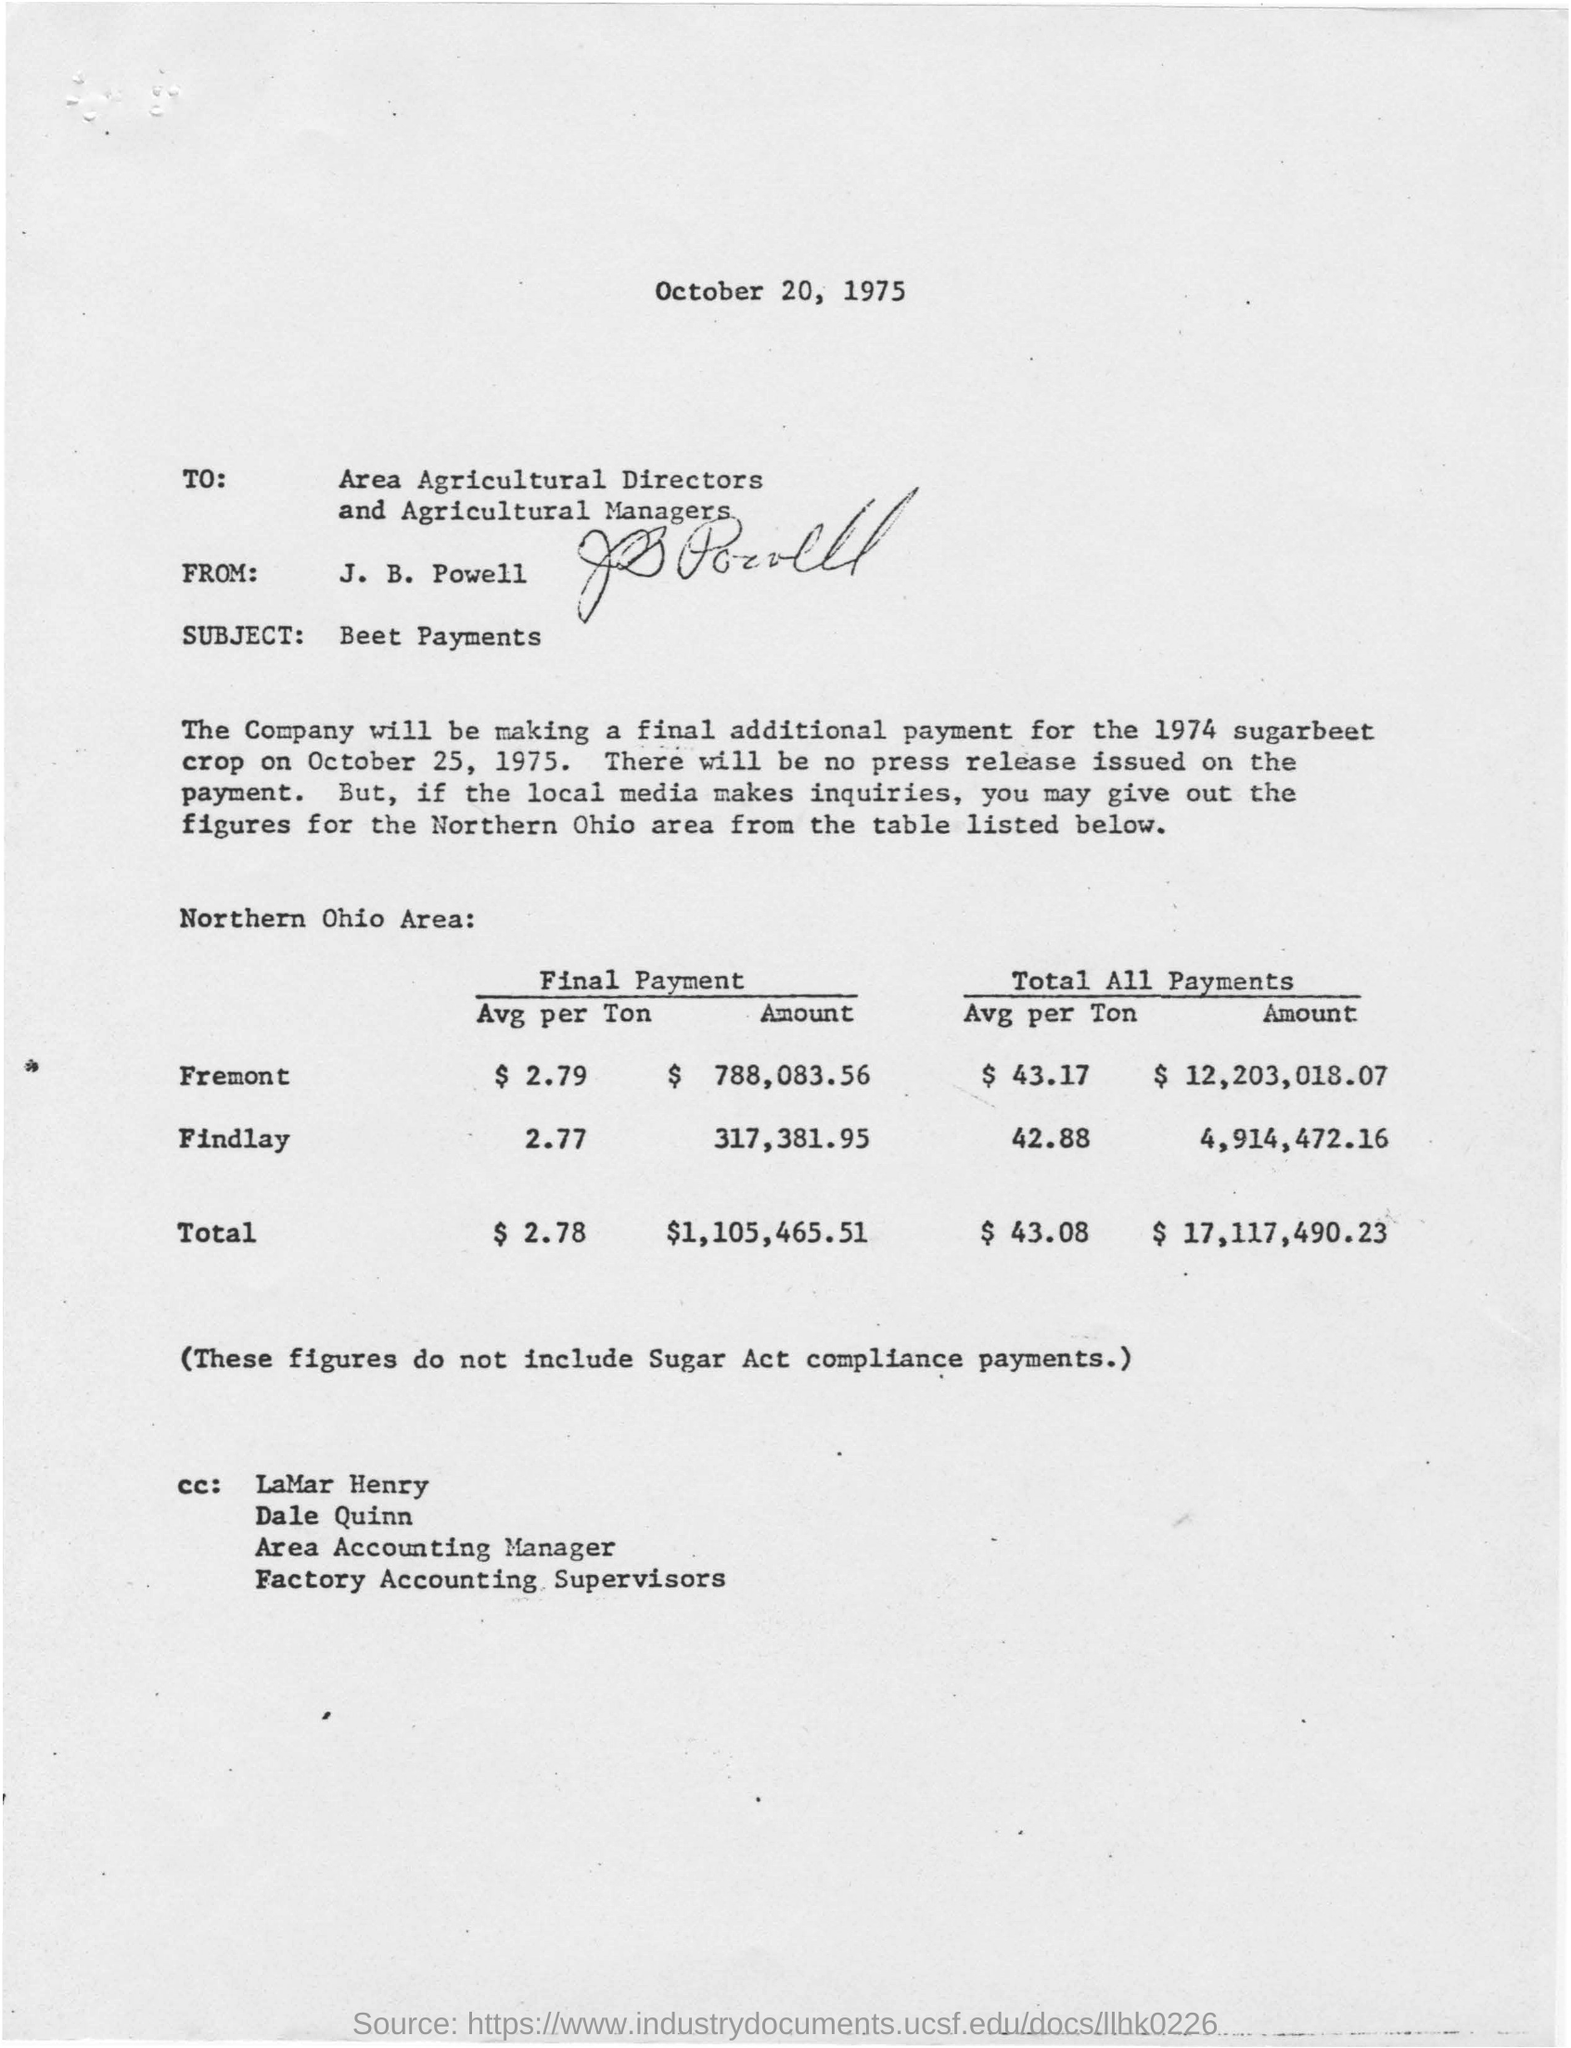What  is the letter about?
Your answer should be compact. About Beet Payments. Which area is studied from the table given?
Keep it short and to the point. The Northern Ohio. When is the letter dated?
Offer a terse response. October 20, 1975. When is the final payment for the sugar beet crop made?
Provide a short and direct response. October 25, 1975. 